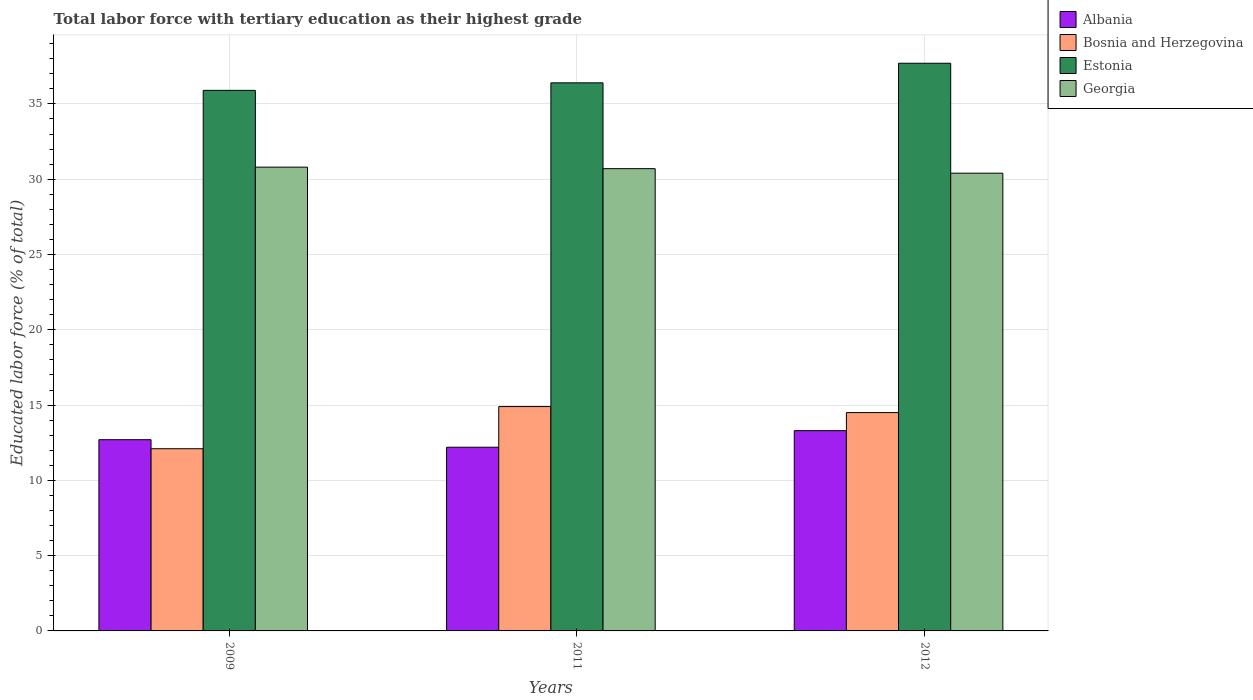How many groups of bars are there?
Provide a succinct answer. 3. Are the number of bars on each tick of the X-axis equal?
Offer a terse response. Yes. In how many cases, is the number of bars for a given year not equal to the number of legend labels?
Your answer should be compact. 0. What is the percentage of male labor force with tertiary education in Albania in 2009?
Give a very brief answer. 12.7. Across all years, what is the maximum percentage of male labor force with tertiary education in Bosnia and Herzegovina?
Provide a succinct answer. 14.9. Across all years, what is the minimum percentage of male labor force with tertiary education in Albania?
Offer a terse response. 12.2. In which year was the percentage of male labor force with tertiary education in Albania minimum?
Offer a very short reply. 2011. What is the total percentage of male labor force with tertiary education in Estonia in the graph?
Provide a succinct answer. 110. What is the difference between the percentage of male labor force with tertiary education in Bosnia and Herzegovina in 2011 and that in 2012?
Give a very brief answer. 0.4. What is the difference between the percentage of male labor force with tertiary education in Albania in 2009 and the percentage of male labor force with tertiary education in Bosnia and Herzegovina in 2012?
Your response must be concise. -1.8. What is the average percentage of male labor force with tertiary education in Estonia per year?
Provide a succinct answer. 36.67. In the year 2012, what is the difference between the percentage of male labor force with tertiary education in Albania and percentage of male labor force with tertiary education in Bosnia and Herzegovina?
Provide a short and direct response. -1.2. In how many years, is the percentage of male labor force with tertiary education in Georgia greater than 23 %?
Provide a short and direct response. 3. What is the ratio of the percentage of male labor force with tertiary education in Estonia in 2009 to that in 2012?
Your answer should be very brief. 0.95. Is the percentage of male labor force with tertiary education in Georgia in 2009 less than that in 2012?
Offer a very short reply. No. What is the difference between the highest and the second highest percentage of male labor force with tertiary education in Albania?
Offer a very short reply. 0.6. What is the difference between the highest and the lowest percentage of male labor force with tertiary education in Estonia?
Your response must be concise. 1.8. Is the sum of the percentage of male labor force with tertiary education in Georgia in 2011 and 2012 greater than the maximum percentage of male labor force with tertiary education in Bosnia and Herzegovina across all years?
Offer a very short reply. Yes. Is it the case that in every year, the sum of the percentage of male labor force with tertiary education in Bosnia and Herzegovina and percentage of male labor force with tertiary education in Albania is greater than the sum of percentage of male labor force with tertiary education in Georgia and percentage of male labor force with tertiary education in Estonia?
Provide a short and direct response. No. What does the 2nd bar from the left in 2011 represents?
Your answer should be compact. Bosnia and Herzegovina. What does the 4th bar from the right in 2012 represents?
Your answer should be compact. Albania. Is it the case that in every year, the sum of the percentage of male labor force with tertiary education in Bosnia and Herzegovina and percentage of male labor force with tertiary education in Albania is greater than the percentage of male labor force with tertiary education in Georgia?
Your answer should be compact. No. How many bars are there?
Make the answer very short. 12. How many years are there in the graph?
Make the answer very short. 3. What is the difference between two consecutive major ticks on the Y-axis?
Give a very brief answer. 5. Are the values on the major ticks of Y-axis written in scientific E-notation?
Provide a short and direct response. No. Does the graph contain any zero values?
Your answer should be compact. No. Does the graph contain grids?
Your answer should be very brief. Yes. Where does the legend appear in the graph?
Provide a short and direct response. Top right. How many legend labels are there?
Provide a short and direct response. 4. What is the title of the graph?
Ensure brevity in your answer.  Total labor force with tertiary education as their highest grade. What is the label or title of the Y-axis?
Your answer should be very brief. Educated labor force (% of total). What is the Educated labor force (% of total) in Albania in 2009?
Offer a terse response. 12.7. What is the Educated labor force (% of total) of Bosnia and Herzegovina in 2009?
Your response must be concise. 12.1. What is the Educated labor force (% of total) of Estonia in 2009?
Provide a succinct answer. 35.9. What is the Educated labor force (% of total) in Georgia in 2009?
Provide a succinct answer. 30.8. What is the Educated labor force (% of total) of Albania in 2011?
Ensure brevity in your answer.  12.2. What is the Educated labor force (% of total) of Bosnia and Herzegovina in 2011?
Your answer should be compact. 14.9. What is the Educated labor force (% of total) in Estonia in 2011?
Ensure brevity in your answer.  36.4. What is the Educated labor force (% of total) of Georgia in 2011?
Make the answer very short. 30.7. What is the Educated labor force (% of total) in Albania in 2012?
Provide a short and direct response. 13.3. What is the Educated labor force (% of total) in Bosnia and Herzegovina in 2012?
Your answer should be very brief. 14.5. What is the Educated labor force (% of total) of Estonia in 2012?
Make the answer very short. 37.7. What is the Educated labor force (% of total) of Georgia in 2012?
Offer a very short reply. 30.4. Across all years, what is the maximum Educated labor force (% of total) in Albania?
Your answer should be very brief. 13.3. Across all years, what is the maximum Educated labor force (% of total) of Bosnia and Herzegovina?
Ensure brevity in your answer.  14.9. Across all years, what is the maximum Educated labor force (% of total) in Estonia?
Provide a succinct answer. 37.7. Across all years, what is the maximum Educated labor force (% of total) of Georgia?
Offer a terse response. 30.8. Across all years, what is the minimum Educated labor force (% of total) in Albania?
Your answer should be compact. 12.2. Across all years, what is the minimum Educated labor force (% of total) of Bosnia and Herzegovina?
Your answer should be compact. 12.1. Across all years, what is the minimum Educated labor force (% of total) of Estonia?
Your answer should be compact. 35.9. Across all years, what is the minimum Educated labor force (% of total) of Georgia?
Your answer should be very brief. 30.4. What is the total Educated labor force (% of total) in Albania in the graph?
Your response must be concise. 38.2. What is the total Educated labor force (% of total) of Bosnia and Herzegovina in the graph?
Provide a short and direct response. 41.5. What is the total Educated labor force (% of total) in Estonia in the graph?
Your answer should be compact. 110. What is the total Educated labor force (% of total) of Georgia in the graph?
Offer a terse response. 91.9. What is the difference between the Educated labor force (% of total) in Albania in 2009 and that in 2011?
Offer a very short reply. 0.5. What is the difference between the Educated labor force (% of total) of Bosnia and Herzegovina in 2009 and that in 2011?
Ensure brevity in your answer.  -2.8. What is the difference between the Educated labor force (% of total) in Estonia in 2009 and that in 2011?
Your answer should be compact. -0.5. What is the difference between the Educated labor force (% of total) of Bosnia and Herzegovina in 2009 and that in 2012?
Give a very brief answer. -2.4. What is the difference between the Educated labor force (% of total) of Estonia in 2009 and that in 2012?
Give a very brief answer. -1.8. What is the difference between the Educated labor force (% of total) in Bosnia and Herzegovina in 2011 and that in 2012?
Your answer should be very brief. 0.4. What is the difference between the Educated labor force (% of total) in Estonia in 2011 and that in 2012?
Keep it short and to the point. -1.3. What is the difference between the Educated labor force (% of total) of Albania in 2009 and the Educated labor force (% of total) of Bosnia and Herzegovina in 2011?
Your response must be concise. -2.2. What is the difference between the Educated labor force (% of total) in Albania in 2009 and the Educated labor force (% of total) in Estonia in 2011?
Keep it short and to the point. -23.7. What is the difference between the Educated labor force (% of total) of Albania in 2009 and the Educated labor force (% of total) of Georgia in 2011?
Your answer should be very brief. -18. What is the difference between the Educated labor force (% of total) in Bosnia and Herzegovina in 2009 and the Educated labor force (% of total) in Estonia in 2011?
Offer a very short reply. -24.3. What is the difference between the Educated labor force (% of total) of Bosnia and Herzegovina in 2009 and the Educated labor force (% of total) of Georgia in 2011?
Provide a succinct answer. -18.6. What is the difference between the Educated labor force (% of total) in Estonia in 2009 and the Educated labor force (% of total) in Georgia in 2011?
Your answer should be compact. 5.2. What is the difference between the Educated labor force (% of total) in Albania in 2009 and the Educated labor force (% of total) in Bosnia and Herzegovina in 2012?
Provide a short and direct response. -1.8. What is the difference between the Educated labor force (% of total) in Albania in 2009 and the Educated labor force (% of total) in Georgia in 2012?
Offer a terse response. -17.7. What is the difference between the Educated labor force (% of total) in Bosnia and Herzegovina in 2009 and the Educated labor force (% of total) in Estonia in 2012?
Offer a terse response. -25.6. What is the difference between the Educated labor force (% of total) of Bosnia and Herzegovina in 2009 and the Educated labor force (% of total) of Georgia in 2012?
Make the answer very short. -18.3. What is the difference between the Educated labor force (% of total) of Estonia in 2009 and the Educated labor force (% of total) of Georgia in 2012?
Provide a short and direct response. 5.5. What is the difference between the Educated labor force (% of total) of Albania in 2011 and the Educated labor force (% of total) of Estonia in 2012?
Your answer should be very brief. -25.5. What is the difference between the Educated labor force (% of total) of Albania in 2011 and the Educated labor force (% of total) of Georgia in 2012?
Your answer should be very brief. -18.2. What is the difference between the Educated labor force (% of total) in Bosnia and Herzegovina in 2011 and the Educated labor force (% of total) in Estonia in 2012?
Your answer should be very brief. -22.8. What is the difference between the Educated labor force (% of total) in Bosnia and Herzegovina in 2011 and the Educated labor force (% of total) in Georgia in 2012?
Keep it short and to the point. -15.5. What is the difference between the Educated labor force (% of total) of Estonia in 2011 and the Educated labor force (% of total) of Georgia in 2012?
Make the answer very short. 6. What is the average Educated labor force (% of total) of Albania per year?
Keep it short and to the point. 12.73. What is the average Educated labor force (% of total) of Bosnia and Herzegovina per year?
Give a very brief answer. 13.83. What is the average Educated labor force (% of total) of Estonia per year?
Provide a succinct answer. 36.67. What is the average Educated labor force (% of total) in Georgia per year?
Your answer should be very brief. 30.63. In the year 2009, what is the difference between the Educated labor force (% of total) of Albania and Educated labor force (% of total) of Bosnia and Herzegovina?
Make the answer very short. 0.6. In the year 2009, what is the difference between the Educated labor force (% of total) in Albania and Educated labor force (% of total) in Estonia?
Keep it short and to the point. -23.2. In the year 2009, what is the difference between the Educated labor force (% of total) in Albania and Educated labor force (% of total) in Georgia?
Offer a terse response. -18.1. In the year 2009, what is the difference between the Educated labor force (% of total) in Bosnia and Herzegovina and Educated labor force (% of total) in Estonia?
Make the answer very short. -23.8. In the year 2009, what is the difference between the Educated labor force (% of total) in Bosnia and Herzegovina and Educated labor force (% of total) in Georgia?
Your response must be concise. -18.7. In the year 2011, what is the difference between the Educated labor force (% of total) of Albania and Educated labor force (% of total) of Bosnia and Herzegovina?
Offer a very short reply. -2.7. In the year 2011, what is the difference between the Educated labor force (% of total) of Albania and Educated labor force (% of total) of Estonia?
Your response must be concise. -24.2. In the year 2011, what is the difference between the Educated labor force (% of total) of Albania and Educated labor force (% of total) of Georgia?
Your answer should be compact. -18.5. In the year 2011, what is the difference between the Educated labor force (% of total) of Bosnia and Herzegovina and Educated labor force (% of total) of Estonia?
Make the answer very short. -21.5. In the year 2011, what is the difference between the Educated labor force (% of total) in Bosnia and Herzegovina and Educated labor force (% of total) in Georgia?
Provide a succinct answer. -15.8. In the year 2011, what is the difference between the Educated labor force (% of total) of Estonia and Educated labor force (% of total) of Georgia?
Your response must be concise. 5.7. In the year 2012, what is the difference between the Educated labor force (% of total) of Albania and Educated labor force (% of total) of Bosnia and Herzegovina?
Your response must be concise. -1.2. In the year 2012, what is the difference between the Educated labor force (% of total) of Albania and Educated labor force (% of total) of Estonia?
Your answer should be compact. -24.4. In the year 2012, what is the difference between the Educated labor force (% of total) of Albania and Educated labor force (% of total) of Georgia?
Ensure brevity in your answer.  -17.1. In the year 2012, what is the difference between the Educated labor force (% of total) of Bosnia and Herzegovina and Educated labor force (% of total) of Estonia?
Offer a very short reply. -23.2. In the year 2012, what is the difference between the Educated labor force (% of total) of Bosnia and Herzegovina and Educated labor force (% of total) of Georgia?
Offer a very short reply. -15.9. What is the ratio of the Educated labor force (% of total) of Albania in 2009 to that in 2011?
Your answer should be very brief. 1.04. What is the ratio of the Educated labor force (% of total) of Bosnia and Herzegovina in 2009 to that in 2011?
Keep it short and to the point. 0.81. What is the ratio of the Educated labor force (% of total) of Estonia in 2009 to that in 2011?
Ensure brevity in your answer.  0.99. What is the ratio of the Educated labor force (% of total) of Albania in 2009 to that in 2012?
Keep it short and to the point. 0.95. What is the ratio of the Educated labor force (% of total) of Bosnia and Herzegovina in 2009 to that in 2012?
Offer a terse response. 0.83. What is the ratio of the Educated labor force (% of total) of Estonia in 2009 to that in 2012?
Provide a short and direct response. 0.95. What is the ratio of the Educated labor force (% of total) of Georgia in 2009 to that in 2012?
Provide a succinct answer. 1.01. What is the ratio of the Educated labor force (% of total) in Albania in 2011 to that in 2012?
Your answer should be very brief. 0.92. What is the ratio of the Educated labor force (% of total) of Bosnia and Herzegovina in 2011 to that in 2012?
Make the answer very short. 1.03. What is the ratio of the Educated labor force (% of total) in Estonia in 2011 to that in 2012?
Give a very brief answer. 0.97. What is the ratio of the Educated labor force (% of total) of Georgia in 2011 to that in 2012?
Give a very brief answer. 1.01. What is the difference between the highest and the second highest Educated labor force (% of total) of Bosnia and Herzegovina?
Your answer should be very brief. 0.4. What is the difference between the highest and the second highest Educated labor force (% of total) of Estonia?
Ensure brevity in your answer.  1.3. What is the difference between the highest and the second highest Educated labor force (% of total) in Georgia?
Offer a very short reply. 0.1. What is the difference between the highest and the lowest Educated labor force (% of total) of Albania?
Give a very brief answer. 1.1. What is the difference between the highest and the lowest Educated labor force (% of total) of Estonia?
Give a very brief answer. 1.8. What is the difference between the highest and the lowest Educated labor force (% of total) of Georgia?
Your answer should be very brief. 0.4. 